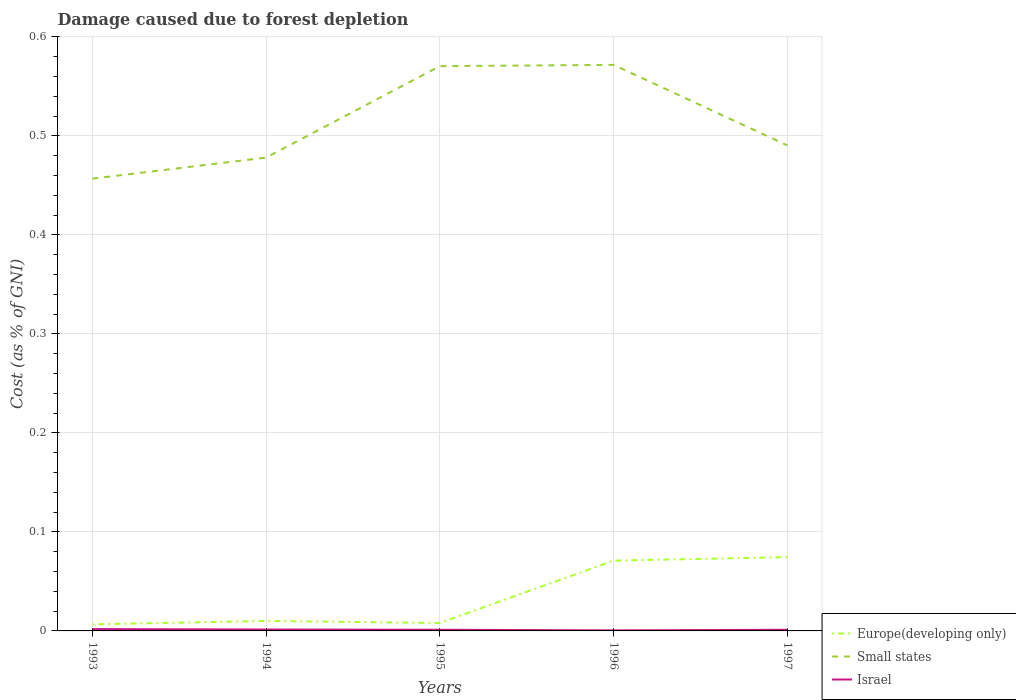How many different coloured lines are there?
Your answer should be compact. 3. Across all years, what is the maximum cost of damage caused due to forest depletion in Europe(developing only)?
Keep it short and to the point. 0.01. In which year was the cost of damage caused due to forest depletion in Israel maximum?
Keep it short and to the point. 1996. What is the total cost of damage caused due to forest depletion in Small states in the graph?
Your answer should be very brief. -0.09. What is the difference between the highest and the second highest cost of damage caused due to forest depletion in Israel?
Make the answer very short. 0. What is the difference between the highest and the lowest cost of damage caused due to forest depletion in Small states?
Offer a terse response. 2. Is the cost of damage caused due to forest depletion in Europe(developing only) strictly greater than the cost of damage caused due to forest depletion in Small states over the years?
Provide a succinct answer. Yes. How many years are there in the graph?
Keep it short and to the point. 5. Does the graph contain grids?
Offer a very short reply. Yes. How are the legend labels stacked?
Your response must be concise. Vertical. What is the title of the graph?
Provide a short and direct response. Damage caused due to forest depletion. What is the label or title of the Y-axis?
Keep it short and to the point. Cost (as % of GNI). What is the Cost (as % of GNI) of Europe(developing only) in 1993?
Your answer should be very brief. 0.01. What is the Cost (as % of GNI) in Small states in 1993?
Provide a short and direct response. 0.46. What is the Cost (as % of GNI) in Israel in 1993?
Provide a succinct answer. 0. What is the Cost (as % of GNI) in Europe(developing only) in 1994?
Offer a very short reply. 0.01. What is the Cost (as % of GNI) in Small states in 1994?
Keep it short and to the point. 0.48. What is the Cost (as % of GNI) in Israel in 1994?
Your answer should be compact. 0. What is the Cost (as % of GNI) in Europe(developing only) in 1995?
Your answer should be very brief. 0.01. What is the Cost (as % of GNI) of Small states in 1995?
Offer a very short reply. 0.57. What is the Cost (as % of GNI) in Israel in 1995?
Offer a terse response. 0. What is the Cost (as % of GNI) in Europe(developing only) in 1996?
Provide a succinct answer. 0.07. What is the Cost (as % of GNI) in Small states in 1996?
Keep it short and to the point. 0.57. What is the Cost (as % of GNI) of Israel in 1996?
Ensure brevity in your answer.  0. What is the Cost (as % of GNI) of Europe(developing only) in 1997?
Provide a succinct answer. 0.07. What is the Cost (as % of GNI) in Small states in 1997?
Ensure brevity in your answer.  0.49. What is the Cost (as % of GNI) in Israel in 1997?
Offer a very short reply. 0. Across all years, what is the maximum Cost (as % of GNI) in Europe(developing only)?
Your response must be concise. 0.07. Across all years, what is the maximum Cost (as % of GNI) of Small states?
Provide a short and direct response. 0.57. Across all years, what is the maximum Cost (as % of GNI) of Israel?
Your answer should be very brief. 0. Across all years, what is the minimum Cost (as % of GNI) of Europe(developing only)?
Give a very brief answer. 0.01. Across all years, what is the minimum Cost (as % of GNI) in Small states?
Offer a very short reply. 0.46. Across all years, what is the minimum Cost (as % of GNI) of Israel?
Your response must be concise. 0. What is the total Cost (as % of GNI) in Europe(developing only) in the graph?
Your answer should be very brief. 0.17. What is the total Cost (as % of GNI) in Small states in the graph?
Your answer should be compact. 2.57. What is the total Cost (as % of GNI) of Israel in the graph?
Provide a short and direct response. 0.01. What is the difference between the Cost (as % of GNI) in Europe(developing only) in 1993 and that in 1994?
Your response must be concise. -0. What is the difference between the Cost (as % of GNI) of Small states in 1993 and that in 1994?
Offer a terse response. -0.02. What is the difference between the Cost (as % of GNI) of Europe(developing only) in 1993 and that in 1995?
Your response must be concise. -0. What is the difference between the Cost (as % of GNI) in Small states in 1993 and that in 1995?
Offer a terse response. -0.11. What is the difference between the Cost (as % of GNI) of Israel in 1993 and that in 1995?
Your answer should be compact. 0. What is the difference between the Cost (as % of GNI) in Europe(developing only) in 1993 and that in 1996?
Keep it short and to the point. -0.06. What is the difference between the Cost (as % of GNI) of Small states in 1993 and that in 1996?
Keep it short and to the point. -0.11. What is the difference between the Cost (as % of GNI) of Israel in 1993 and that in 1996?
Your response must be concise. 0. What is the difference between the Cost (as % of GNI) of Europe(developing only) in 1993 and that in 1997?
Give a very brief answer. -0.07. What is the difference between the Cost (as % of GNI) in Small states in 1993 and that in 1997?
Your response must be concise. -0.03. What is the difference between the Cost (as % of GNI) in Israel in 1993 and that in 1997?
Ensure brevity in your answer.  0. What is the difference between the Cost (as % of GNI) in Europe(developing only) in 1994 and that in 1995?
Your answer should be very brief. 0. What is the difference between the Cost (as % of GNI) of Small states in 1994 and that in 1995?
Offer a terse response. -0.09. What is the difference between the Cost (as % of GNI) in Europe(developing only) in 1994 and that in 1996?
Make the answer very short. -0.06. What is the difference between the Cost (as % of GNI) in Small states in 1994 and that in 1996?
Make the answer very short. -0.09. What is the difference between the Cost (as % of GNI) in Israel in 1994 and that in 1996?
Offer a terse response. 0. What is the difference between the Cost (as % of GNI) of Europe(developing only) in 1994 and that in 1997?
Your response must be concise. -0.06. What is the difference between the Cost (as % of GNI) of Small states in 1994 and that in 1997?
Your response must be concise. -0.01. What is the difference between the Cost (as % of GNI) of Israel in 1994 and that in 1997?
Provide a succinct answer. 0. What is the difference between the Cost (as % of GNI) of Europe(developing only) in 1995 and that in 1996?
Ensure brevity in your answer.  -0.06. What is the difference between the Cost (as % of GNI) of Small states in 1995 and that in 1996?
Your answer should be compact. -0. What is the difference between the Cost (as % of GNI) of Israel in 1995 and that in 1996?
Ensure brevity in your answer.  0. What is the difference between the Cost (as % of GNI) of Europe(developing only) in 1995 and that in 1997?
Make the answer very short. -0.07. What is the difference between the Cost (as % of GNI) in Small states in 1995 and that in 1997?
Keep it short and to the point. 0.08. What is the difference between the Cost (as % of GNI) in Europe(developing only) in 1996 and that in 1997?
Keep it short and to the point. -0. What is the difference between the Cost (as % of GNI) in Small states in 1996 and that in 1997?
Offer a terse response. 0.08. What is the difference between the Cost (as % of GNI) of Israel in 1996 and that in 1997?
Provide a succinct answer. -0. What is the difference between the Cost (as % of GNI) of Europe(developing only) in 1993 and the Cost (as % of GNI) of Small states in 1994?
Provide a succinct answer. -0.47. What is the difference between the Cost (as % of GNI) of Europe(developing only) in 1993 and the Cost (as % of GNI) of Israel in 1994?
Your response must be concise. 0.01. What is the difference between the Cost (as % of GNI) in Small states in 1993 and the Cost (as % of GNI) in Israel in 1994?
Ensure brevity in your answer.  0.46. What is the difference between the Cost (as % of GNI) of Europe(developing only) in 1993 and the Cost (as % of GNI) of Small states in 1995?
Offer a terse response. -0.56. What is the difference between the Cost (as % of GNI) in Europe(developing only) in 1993 and the Cost (as % of GNI) in Israel in 1995?
Your response must be concise. 0.01. What is the difference between the Cost (as % of GNI) of Small states in 1993 and the Cost (as % of GNI) of Israel in 1995?
Keep it short and to the point. 0.46. What is the difference between the Cost (as % of GNI) of Europe(developing only) in 1993 and the Cost (as % of GNI) of Small states in 1996?
Give a very brief answer. -0.57. What is the difference between the Cost (as % of GNI) of Europe(developing only) in 1993 and the Cost (as % of GNI) of Israel in 1996?
Your response must be concise. 0.01. What is the difference between the Cost (as % of GNI) in Small states in 1993 and the Cost (as % of GNI) in Israel in 1996?
Offer a terse response. 0.46. What is the difference between the Cost (as % of GNI) of Europe(developing only) in 1993 and the Cost (as % of GNI) of Small states in 1997?
Offer a terse response. -0.48. What is the difference between the Cost (as % of GNI) of Europe(developing only) in 1993 and the Cost (as % of GNI) of Israel in 1997?
Provide a succinct answer. 0.01. What is the difference between the Cost (as % of GNI) in Small states in 1993 and the Cost (as % of GNI) in Israel in 1997?
Give a very brief answer. 0.46. What is the difference between the Cost (as % of GNI) in Europe(developing only) in 1994 and the Cost (as % of GNI) in Small states in 1995?
Give a very brief answer. -0.56. What is the difference between the Cost (as % of GNI) of Europe(developing only) in 1994 and the Cost (as % of GNI) of Israel in 1995?
Offer a very short reply. 0.01. What is the difference between the Cost (as % of GNI) of Small states in 1994 and the Cost (as % of GNI) of Israel in 1995?
Give a very brief answer. 0.48. What is the difference between the Cost (as % of GNI) in Europe(developing only) in 1994 and the Cost (as % of GNI) in Small states in 1996?
Keep it short and to the point. -0.56. What is the difference between the Cost (as % of GNI) of Europe(developing only) in 1994 and the Cost (as % of GNI) of Israel in 1996?
Provide a short and direct response. 0.01. What is the difference between the Cost (as % of GNI) of Small states in 1994 and the Cost (as % of GNI) of Israel in 1996?
Your response must be concise. 0.48. What is the difference between the Cost (as % of GNI) in Europe(developing only) in 1994 and the Cost (as % of GNI) in Small states in 1997?
Keep it short and to the point. -0.48. What is the difference between the Cost (as % of GNI) of Europe(developing only) in 1994 and the Cost (as % of GNI) of Israel in 1997?
Keep it short and to the point. 0.01. What is the difference between the Cost (as % of GNI) in Small states in 1994 and the Cost (as % of GNI) in Israel in 1997?
Keep it short and to the point. 0.48. What is the difference between the Cost (as % of GNI) of Europe(developing only) in 1995 and the Cost (as % of GNI) of Small states in 1996?
Offer a terse response. -0.56. What is the difference between the Cost (as % of GNI) of Europe(developing only) in 1995 and the Cost (as % of GNI) of Israel in 1996?
Offer a very short reply. 0.01. What is the difference between the Cost (as % of GNI) of Small states in 1995 and the Cost (as % of GNI) of Israel in 1996?
Ensure brevity in your answer.  0.57. What is the difference between the Cost (as % of GNI) in Europe(developing only) in 1995 and the Cost (as % of GNI) in Small states in 1997?
Offer a terse response. -0.48. What is the difference between the Cost (as % of GNI) in Europe(developing only) in 1995 and the Cost (as % of GNI) in Israel in 1997?
Your answer should be compact. 0.01. What is the difference between the Cost (as % of GNI) of Small states in 1995 and the Cost (as % of GNI) of Israel in 1997?
Your answer should be very brief. 0.57. What is the difference between the Cost (as % of GNI) of Europe(developing only) in 1996 and the Cost (as % of GNI) of Small states in 1997?
Your answer should be compact. -0.42. What is the difference between the Cost (as % of GNI) in Europe(developing only) in 1996 and the Cost (as % of GNI) in Israel in 1997?
Offer a very short reply. 0.07. What is the difference between the Cost (as % of GNI) of Small states in 1996 and the Cost (as % of GNI) of Israel in 1997?
Offer a terse response. 0.57. What is the average Cost (as % of GNI) in Europe(developing only) per year?
Provide a succinct answer. 0.03. What is the average Cost (as % of GNI) in Small states per year?
Provide a succinct answer. 0.51. What is the average Cost (as % of GNI) in Israel per year?
Offer a very short reply. 0. In the year 1993, what is the difference between the Cost (as % of GNI) in Europe(developing only) and Cost (as % of GNI) in Small states?
Give a very brief answer. -0.45. In the year 1993, what is the difference between the Cost (as % of GNI) in Europe(developing only) and Cost (as % of GNI) in Israel?
Keep it short and to the point. 0. In the year 1993, what is the difference between the Cost (as % of GNI) of Small states and Cost (as % of GNI) of Israel?
Keep it short and to the point. 0.45. In the year 1994, what is the difference between the Cost (as % of GNI) in Europe(developing only) and Cost (as % of GNI) in Small states?
Make the answer very short. -0.47. In the year 1994, what is the difference between the Cost (as % of GNI) in Europe(developing only) and Cost (as % of GNI) in Israel?
Provide a short and direct response. 0.01. In the year 1994, what is the difference between the Cost (as % of GNI) in Small states and Cost (as % of GNI) in Israel?
Make the answer very short. 0.48. In the year 1995, what is the difference between the Cost (as % of GNI) in Europe(developing only) and Cost (as % of GNI) in Small states?
Your answer should be compact. -0.56. In the year 1995, what is the difference between the Cost (as % of GNI) of Europe(developing only) and Cost (as % of GNI) of Israel?
Give a very brief answer. 0.01. In the year 1995, what is the difference between the Cost (as % of GNI) of Small states and Cost (as % of GNI) of Israel?
Keep it short and to the point. 0.57. In the year 1996, what is the difference between the Cost (as % of GNI) of Europe(developing only) and Cost (as % of GNI) of Small states?
Provide a succinct answer. -0.5. In the year 1996, what is the difference between the Cost (as % of GNI) in Europe(developing only) and Cost (as % of GNI) in Israel?
Give a very brief answer. 0.07. In the year 1996, what is the difference between the Cost (as % of GNI) in Small states and Cost (as % of GNI) in Israel?
Your answer should be very brief. 0.57. In the year 1997, what is the difference between the Cost (as % of GNI) in Europe(developing only) and Cost (as % of GNI) in Small states?
Offer a very short reply. -0.42. In the year 1997, what is the difference between the Cost (as % of GNI) of Europe(developing only) and Cost (as % of GNI) of Israel?
Offer a very short reply. 0.07. In the year 1997, what is the difference between the Cost (as % of GNI) in Small states and Cost (as % of GNI) in Israel?
Offer a very short reply. 0.49. What is the ratio of the Cost (as % of GNI) of Europe(developing only) in 1993 to that in 1994?
Provide a short and direct response. 0.66. What is the ratio of the Cost (as % of GNI) of Small states in 1993 to that in 1994?
Make the answer very short. 0.96. What is the ratio of the Cost (as % of GNI) of Israel in 1993 to that in 1994?
Make the answer very short. 1.31. What is the ratio of the Cost (as % of GNI) of Europe(developing only) in 1993 to that in 1995?
Ensure brevity in your answer.  0.83. What is the ratio of the Cost (as % of GNI) in Small states in 1993 to that in 1995?
Keep it short and to the point. 0.8. What is the ratio of the Cost (as % of GNI) in Israel in 1993 to that in 1995?
Offer a terse response. 1.6. What is the ratio of the Cost (as % of GNI) of Europe(developing only) in 1993 to that in 1996?
Ensure brevity in your answer.  0.09. What is the ratio of the Cost (as % of GNI) in Small states in 1993 to that in 1996?
Provide a succinct answer. 0.8. What is the ratio of the Cost (as % of GNI) in Israel in 1993 to that in 1996?
Make the answer very short. 3.45. What is the ratio of the Cost (as % of GNI) of Europe(developing only) in 1993 to that in 1997?
Provide a short and direct response. 0.09. What is the ratio of the Cost (as % of GNI) in Small states in 1993 to that in 1997?
Offer a terse response. 0.93. What is the ratio of the Cost (as % of GNI) of Israel in 1993 to that in 1997?
Make the answer very short. 1.62. What is the ratio of the Cost (as % of GNI) of Europe(developing only) in 1994 to that in 1995?
Offer a terse response. 1.26. What is the ratio of the Cost (as % of GNI) in Small states in 1994 to that in 1995?
Your answer should be very brief. 0.84. What is the ratio of the Cost (as % of GNI) of Israel in 1994 to that in 1995?
Ensure brevity in your answer.  1.22. What is the ratio of the Cost (as % of GNI) in Europe(developing only) in 1994 to that in 1996?
Provide a short and direct response. 0.14. What is the ratio of the Cost (as % of GNI) of Small states in 1994 to that in 1996?
Ensure brevity in your answer.  0.84. What is the ratio of the Cost (as % of GNI) in Israel in 1994 to that in 1996?
Keep it short and to the point. 2.64. What is the ratio of the Cost (as % of GNI) in Europe(developing only) in 1994 to that in 1997?
Your response must be concise. 0.14. What is the ratio of the Cost (as % of GNI) of Small states in 1994 to that in 1997?
Your answer should be compact. 0.97. What is the ratio of the Cost (as % of GNI) in Israel in 1994 to that in 1997?
Your answer should be compact. 1.24. What is the ratio of the Cost (as % of GNI) in Europe(developing only) in 1995 to that in 1996?
Your answer should be compact. 0.11. What is the ratio of the Cost (as % of GNI) of Small states in 1995 to that in 1996?
Offer a very short reply. 1. What is the ratio of the Cost (as % of GNI) of Israel in 1995 to that in 1996?
Provide a short and direct response. 2.17. What is the ratio of the Cost (as % of GNI) of Europe(developing only) in 1995 to that in 1997?
Your answer should be compact. 0.11. What is the ratio of the Cost (as % of GNI) in Small states in 1995 to that in 1997?
Provide a short and direct response. 1.16. What is the ratio of the Cost (as % of GNI) in Israel in 1995 to that in 1997?
Keep it short and to the point. 1.01. What is the ratio of the Cost (as % of GNI) in Europe(developing only) in 1996 to that in 1997?
Offer a terse response. 0.95. What is the ratio of the Cost (as % of GNI) of Small states in 1996 to that in 1997?
Your answer should be very brief. 1.17. What is the ratio of the Cost (as % of GNI) of Israel in 1996 to that in 1997?
Offer a very short reply. 0.47. What is the difference between the highest and the second highest Cost (as % of GNI) of Europe(developing only)?
Provide a succinct answer. 0. What is the difference between the highest and the second highest Cost (as % of GNI) of Small states?
Offer a terse response. 0. What is the difference between the highest and the second highest Cost (as % of GNI) in Israel?
Offer a terse response. 0. What is the difference between the highest and the lowest Cost (as % of GNI) in Europe(developing only)?
Give a very brief answer. 0.07. What is the difference between the highest and the lowest Cost (as % of GNI) of Small states?
Your answer should be compact. 0.11. What is the difference between the highest and the lowest Cost (as % of GNI) of Israel?
Offer a terse response. 0. 